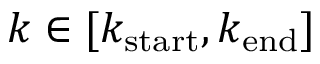Convert formula to latex. <formula><loc_0><loc_0><loc_500><loc_500>k \in [ k _ { s t a r t } , k _ { e n d } ]</formula> 